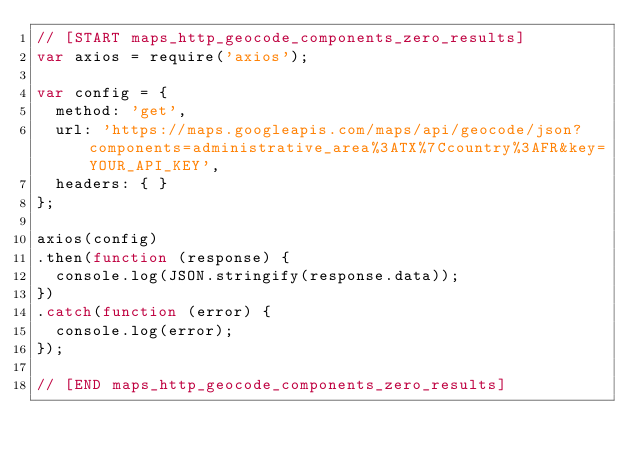Convert code to text. <code><loc_0><loc_0><loc_500><loc_500><_JavaScript_>// [START maps_http_geocode_components_zero_results]
var axios = require('axios');

var config = {
  method: 'get',
  url: 'https://maps.googleapis.com/maps/api/geocode/json?components=administrative_area%3ATX%7Ccountry%3AFR&key=YOUR_API_KEY',
  headers: { }
};

axios(config)
.then(function (response) {
  console.log(JSON.stringify(response.data));
})
.catch(function (error) {
  console.log(error);
});

// [END maps_http_geocode_components_zero_results]</code> 